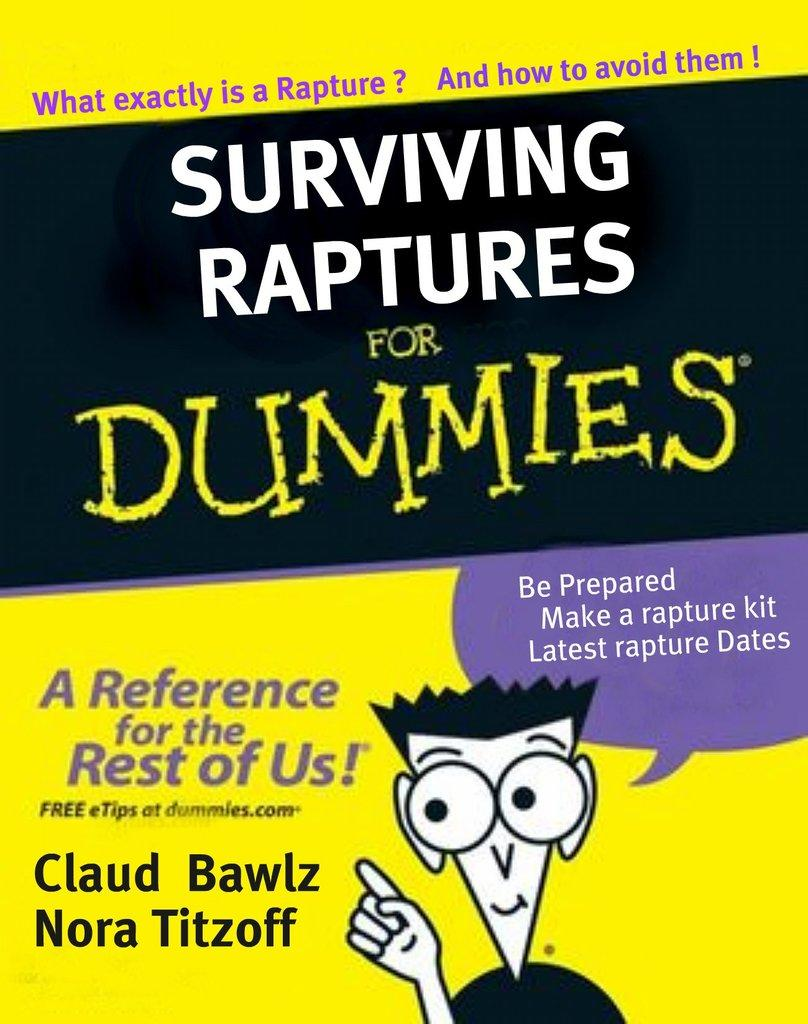<image>
Provide a brief description of the given image. A familiar yellow book claims to be a guide for surviving a rapture. 